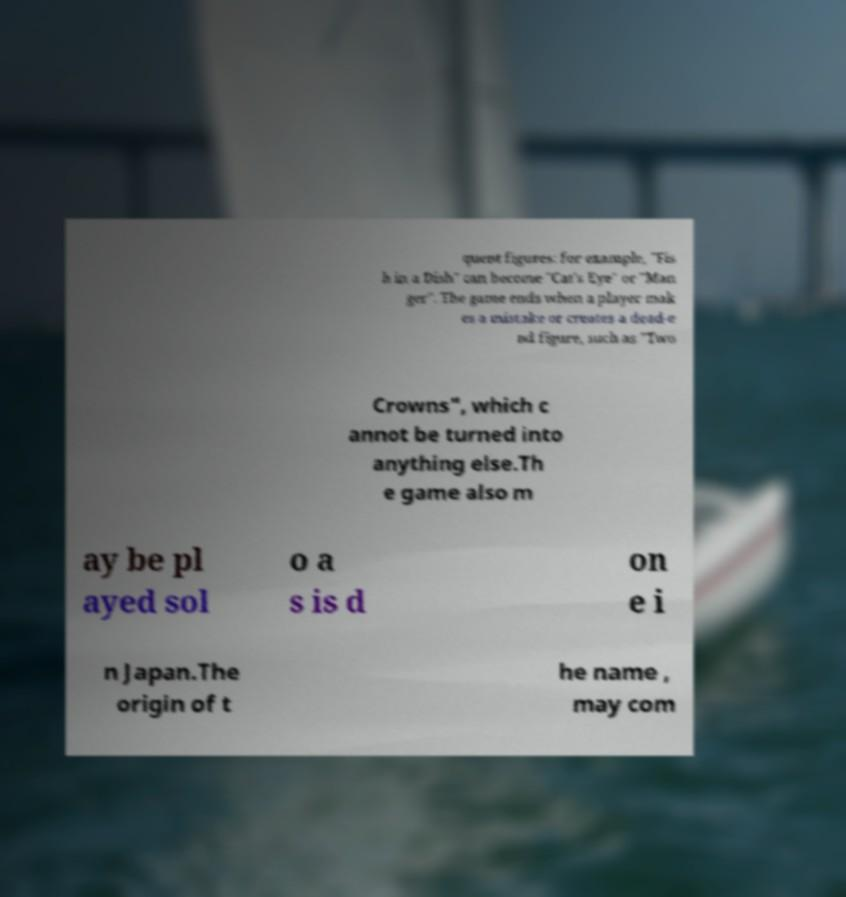What messages or text are displayed in this image? I need them in a readable, typed format. quent figures: for example, "Fis h in a Dish" can become "Cat's Eye" or "Man ger". The game ends when a player mak es a mistake or creates a dead-e nd figure, such as "Two Crowns", which c annot be turned into anything else.Th e game also m ay be pl ayed sol o a s is d on e i n Japan.The origin of t he name , may com 